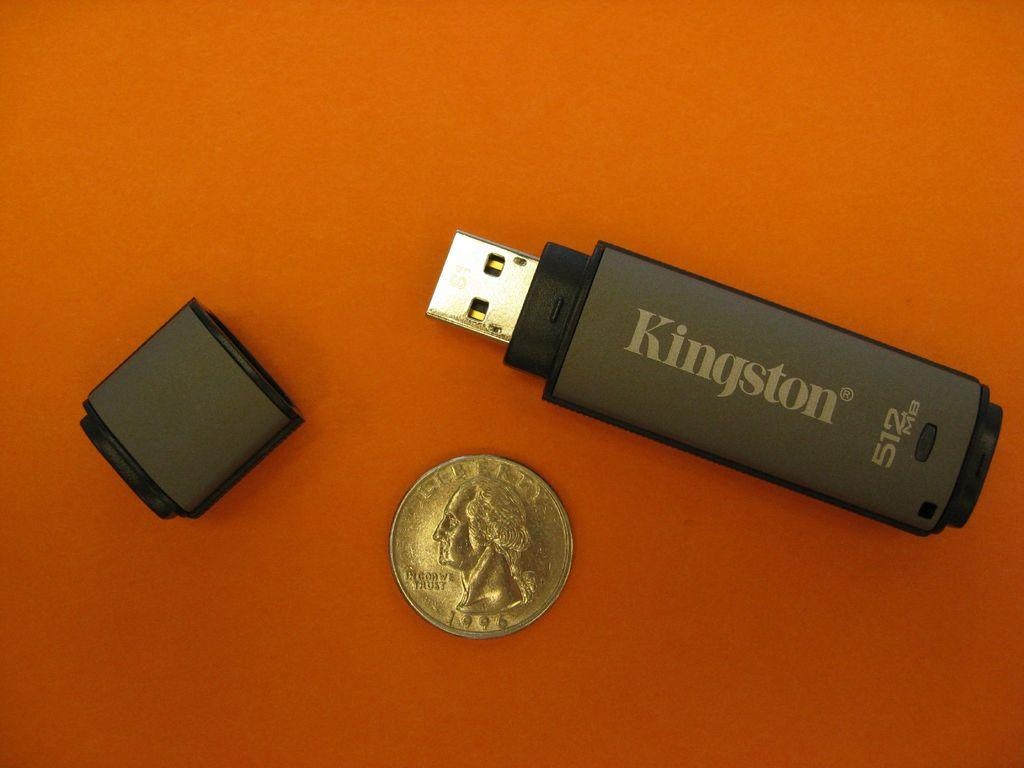<image>
Provide a brief description of the given image. A flash drive by Kingston sits next to a small coin. 